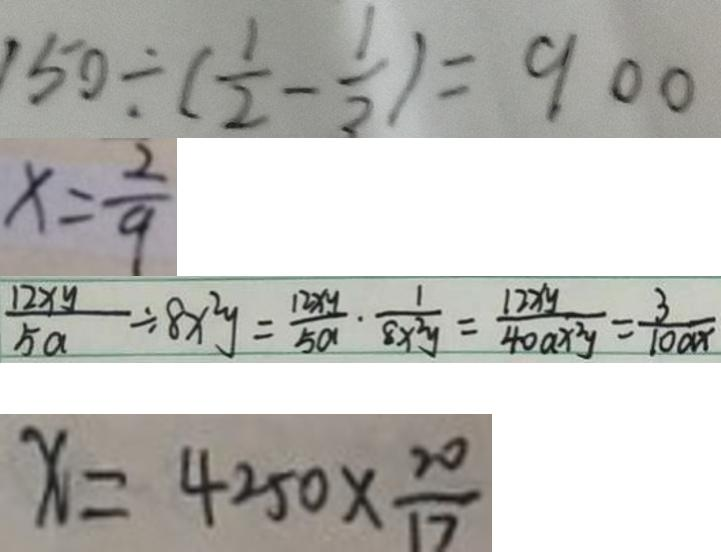<formula> <loc_0><loc_0><loc_500><loc_500>1 5 0 \div ( \frac { 1 } { 2 } - \frac { 1 } { 3 } ) = 9 0 0 
 x = \frac { 2 } { 9 } 
 \frac { 1 2 x y } { 5 a } \div 8 x ^ { 2 } y = \frac { 1 2 x y } { 5 a } \cdot \frac { 1 } { 8 x ^ { 2 } y } = \frac { 1 2 x y } { 4 0 a x ^ { 2 } y } = \frac { 3 } { 1 0 a x } 
 x = 4 2 5 0 \times \frac { 2 0 } { 1 7 }</formula> 